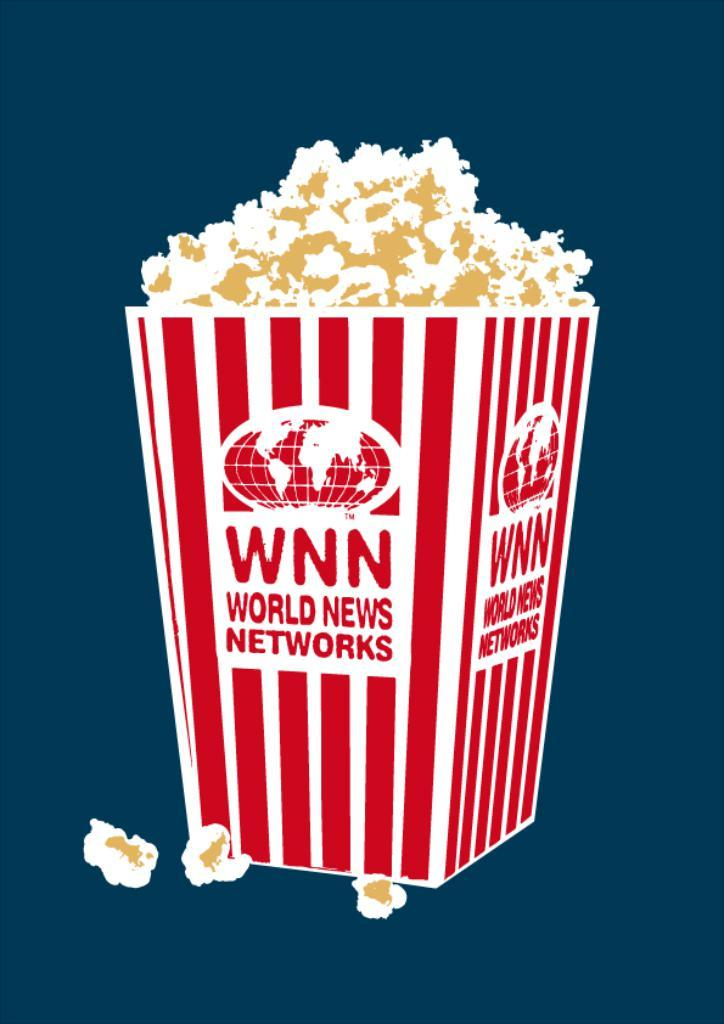What type of food is present in the image? There is popcorn in the image. What color is the background of the image? The background of the image is blue. What type of prison is depicted in the image? There is no prison present in the image; it features popcorn and a blue background. 